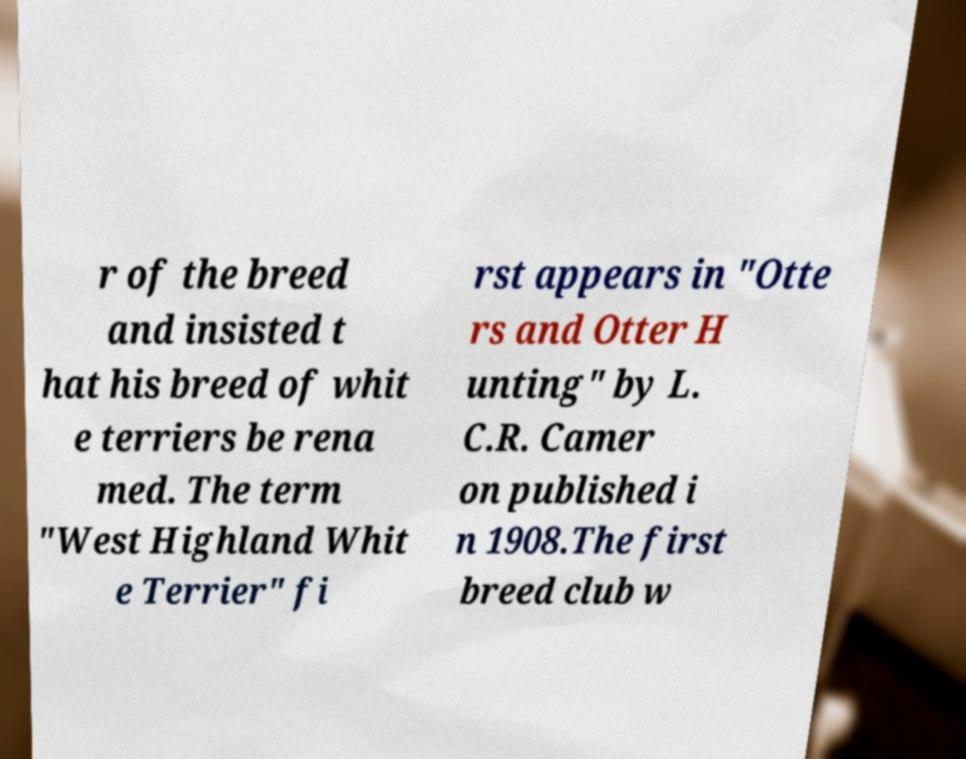Can you read and provide the text displayed in the image?This photo seems to have some interesting text. Can you extract and type it out for me? r of the breed and insisted t hat his breed of whit e terriers be rena med. The term "West Highland Whit e Terrier" fi rst appears in "Otte rs and Otter H unting" by L. C.R. Camer on published i n 1908.The first breed club w 